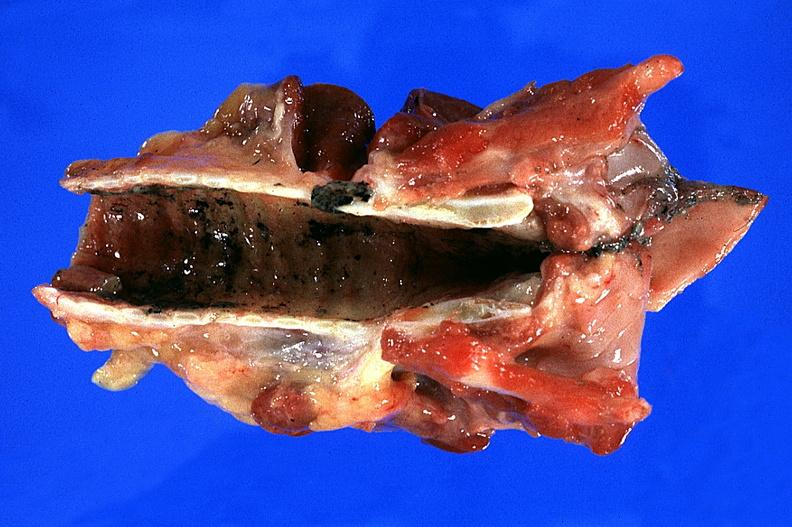what burn smoke inhalation?
Answer the question using a single word or phrase. Thermal 